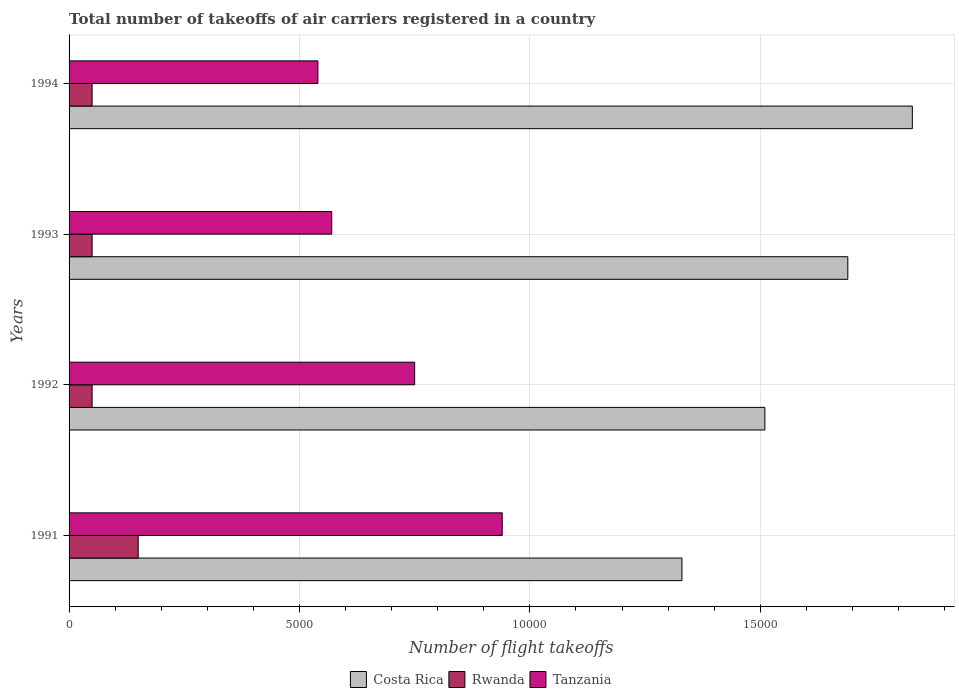How many different coloured bars are there?
Offer a terse response. 3. How many bars are there on the 4th tick from the top?
Your response must be concise. 3. In how many cases, is the number of bars for a given year not equal to the number of legend labels?
Offer a very short reply. 0. What is the total number of flight takeoffs in Tanzania in 1991?
Your response must be concise. 9400. Across all years, what is the maximum total number of flight takeoffs in Rwanda?
Offer a very short reply. 1500. What is the total total number of flight takeoffs in Rwanda in the graph?
Provide a succinct answer. 3000. What is the difference between the total number of flight takeoffs in Costa Rica in 1993 and that in 1994?
Your answer should be very brief. -1400. What is the difference between the total number of flight takeoffs in Rwanda in 1993 and the total number of flight takeoffs in Costa Rica in 1991?
Make the answer very short. -1.28e+04. What is the average total number of flight takeoffs in Costa Rica per year?
Keep it short and to the point. 1.59e+04. In the year 1994, what is the difference between the total number of flight takeoffs in Tanzania and total number of flight takeoffs in Costa Rica?
Offer a terse response. -1.29e+04. Is the difference between the total number of flight takeoffs in Tanzania in 1993 and 1994 greater than the difference between the total number of flight takeoffs in Costa Rica in 1993 and 1994?
Keep it short and to the point. Yes. What is the difference between the highest and the second highest total number of flight takeoffs in Tanzania?
Make the answer very short. 1900. What is the difference between the highest and the lowest total number of flight takeoffs in Rwanda?
Keep it short and to the point. 1000. In how many years, is the total number of flight takeoffs in Rwanda greater than the average total number of flight takeoffs in Rwanda taken over all years?
Provide a succinct answer. 1. Is the sum of the total number of flight takeoffs in Costa Rica in 1991 and 1994 greater than the maximum total number of flight takeoffs in Tanzania across all years?
Your answer should be very brief. Yes. What does the 1st bar from the top in 1993 represents?
Provide a short and direct response. Tanzania. What does the 2nd bar from the bottom in 1993 represents?
Provide a short and direct response. Rwanda. Is it the case that in every year, the sum of the total number of flight takeoffs in Rwanda and total number of flight takeoffs in Tanzania is greater than the total number of flight takeoffs in Costa Rica?
Give a very brief answer. No. How many bars are there?
Give a very brief answer. 12. What is the difference between two consecutive major ticks on the X-axis?
Provide a succinct answer. 5000. Are the values on the major ticks of X-axis written in scientific E-notation?
Ensure brevity in your answer.  No. Does the graph contain any zero values?
Your response must be concise. No. Does the graph contain grids?
Make the answer very short. Yes. Where does the legend appear in the graph?
Your answer should be very brief. Bottom center. How are the legend labels stacked?
Give a very brief answer. Horizontal. What is the title of the graph?
Provide a short and direct response. Total number of takeoffs of air carriers registered in a country. What is the label or title of the X-axis?
Give a very brief answer. Number of flight takeoffs. What is the Number of flight takeoffs of Costa Rica in 1991?
Your answer should be compact. 1.33e+04. What is the Number of flight takeoffs of Rwanda in 1991?
Your response must be concise. 1500. What is the Number of flight takeoffs of Tanzania in 1991?
Your answer should be compact. 9400. What is the Number of flight takeoffs of Costa Rica in 1992?
Offer a terse response. 1.51e+04. What is the Number of flight takeoffs of Tanzania in 1992?
Your response must be concise. 7500. What is the Number of flight takeoffs of Costa Rica in 1993?
Keep it short and to the point. 1.69e+04. What is the Number of flight takeoffs in Tanzania in 1993?
Your answer should be compact. 5700. What is the Number of flight takeoffs in Costa Rica in 1994?
Make the answer very short. 1.83e+04. What is the Number of flight takeoffs in Rwanda in 1994?
Keep it short and to the point. 500. What is the Number of flight takeoffs in Tanzania in 1994?
Your response must be concise. 5400. Across all years, what is the maximum Number of flight takeoffs of Costa Rica?
Ensure brevity in your answer.  1.83e+04. Across all years, what is the maximum Number of flight takeoffs in Rwanda?
Offer a very short reply. 1500. Across all years, what is the maximum Number of flight takeoffs in Tanzania?
Your answer should be compact. 9400. Across all years, what is the minimum Number of flight takeoffs of Costa Rica?
Make the answer very short. 1.33e+04. Across all years, what is the minimum Number of flight takeoffs of Tanzania?
Offer a very short reply. 5400. What is the total Number of flight takeoffs of Costa Rica in the graph?
Give a very brief answer. 6.36e+04. What is the total Number of flight takeoffs of Rwanda in the graph?
Your response must be concise. 3000. What is the total Number of flight takeoffs in Tanzania in the graph?
Make the answer very short. 2.80e+04. What is the difference between the Number of flight takeoffs of Costa Rica in 1991 and that in 1992?
Provide a short and direct response. -1800. What is the difference between the Number of flight takeoffs in Tanzania in 1991 and that in 1992?
Give a very brief answer. 1900. What is the difference between the Number of flight takeoffs in Costa Rica in 1991 and that in 1993?
Offer a terse response. -3600. What is the difference between the Number of flight takeoffs in Rwanda in 1991 and that in 1993?
Make the answer very short. 1000. What is the difference between the Number of flight takeoffs in Tanzania in 1991 and that in 1993?
Give a very brief answer. 3700. What is the difference between the Number of flight takeoffs of Costa Rica in 1991 and that in 1994?
Give a very brief answer. -5000. What is the difference between the Number of flight takeoffs in Rwanda in 1991 and that in 1994?
Provide a succinct answer. 1000. What is the difference between the Number of flight takeoffs of Tanzania in 1991 and that in 1994?
Ensure brevity in your answer.  4000. What is the difference between the Number of flight takeoffs in Costa Rica in 1992 and that in 1993?
Keep it short and to the point. -1800. What is the difference between the Number of flight takeoffs of Rwanda in 1992 and that in 1993?
Keep it short and to the point. 0. What is the difference between the Number of flight takeoffs of Tanzania in 1992 and that in 1993?
Your response must be concise. 1800. What is the difference between the Number of flight takeoffs in Costa Rica in 1992 and that in 1994?
Keep it short and to the point. -3200. What is the difference between the Number of flight takeoffs in Rwanda in 1992 and that in 1994?
Provide a short and direct response. 0. What is the difference between the Number of flight takeoffs in Tanzania in 1992 and that in 1994?
Your answer should be very brief. 2100. What is the difference between the Number of flight takeoffs of Costa Rica in 1993 and that in 1994?
Ensure brevity in your answer.  -1400. What is the difference between the Number of flight takeoffs in Tanzania in 1993 and that in 1994?
Provide a short and direct response. 300. What is the difference between the Number of flight takeoffs in Costa Rica in 1991 and the Number of flight takeoffs in Rwanda in 1992?
Keep it short and to the point. 1.28e+04. What is the difference between the Number of flight takeoffs of Costa Rica in 1991 and the Number of flight takeoffs of Tanzania in 1992?
Your answer should be compact. 5800. What is the difference between the Number of flight takeoffs of Rwanda in 1991 and the Number of flight takeoffs of Tanzania in 1992?
Make the answer very short. -6000. What is the difference between the Number of flight takeoffs of Costa Rica in 1991 and the Number of flight takeoffs of Rwanda in 1993?
Give a very brief answer. 1.28e+04. What is the difference between the Number of flight takeoffs in Costa Rica in 1991 and the Number of flight takeoffs in Tanzania in 1993?
Provide a succinct answer. 7600. What is the difference between the Number of flight takeoffs of Rwanda in 1991 and the Number of flight takeoffs of Tanzania in 1993?
Make the answer very short. -4200. What is the difference between the Number of flight takeoffs in Costa Rica in 1991 and the Number of flight takeoffs in Rwanda in 1994?
Keep it short and to the point. 1.28e+04. What is the difference between the Number of flight takeoffs in Costa Rica in 1991 and the Number of flight takeoffs in Tanzania in 1994?
Your answer should be very brief. 7900. What is the difference between the Number of flight takeoffs in Rwanda in 1991 and the Number of flight takeoffs in Tanzania in 1994?
Offer a very short reply. -3900. What is the difference between the Number of flight takeoffs in Costa Rica in 1992 and the Number of flight takeoffs in Rwanda in 1993?
Provide a succinct answer. 1.46e+04. What is the difference between the Number of flight takeoffs of Costa Rica in 1992 and the Number of flight takeoffs of Tanzania in 1993?
Ensure brevity in your answer.  9400. What is the difference between the Number of flight takeoffs in Rwanda in 1992 and the Number of flight takeoffs in Tanzania in 1993?
Your answer should be very brief. -5200. What is the difference between the Number of flight takeoffs in Costa Rica in 1992 and the Number of flight takeoffs in Rwanda in 1994?
Ensure brevity in your answer.  1.46e+04. What is the difference between the Number of flight takeoffs in Costa Rica in 1992 and the Number of flight takeoffs in Tanzania in 1994?
Offer a terse response. 9700. What is the difference between the Number of flight takeoffs of Rwanda in 1992 and the Number of flight takeoffs of Tanzania in 1994?
Give a very brief answer. -4900. What is the difference between the Number of flight takeoffs of Costa Rica in 1993 and the Number of flight takeoffs of Rwanda in 1994?
Ensure brevity in your answer.  1.64e+04. What is the difference between the Number of flight takeoffs of Costa Rica in 1993 and the Number of flight takeoffs of Tanzania in 1994?
Make the answer very short. 1.15e+04. What is the difference between the Number of flight takeoffs of Rwanda in 1993 and the Number of flight takeoffs of Tanzania in 1994?
Provide a succinct answer. -4900. What is the average Number of flight takeoffs of Costa Rica per year?
Your answer should be compact. 1.59e+04. What is the average Number of flight takeoffs of Rwanda per year?
Ensure brevity in your answer.  750. What is the average Number of flight takeoffs of Tanzania per year?
Your answer should be very brief. 7000. In the year 1991, what is the difference between the Number of flight takeoffs in Costa Rica and Number of flight takeoffs in Rwanda?
Provide a short and direct response. 1.18e+04. In the year 1991, what is the difference between the Number of flight takeoffs of Costa Rica and Number of flight takeoffs of Tanzania?
Ensure brevity in your answer.  3900. In the year 1991, what is the difference between the Number of flight takeoffs in Rwanda and Number of flight takeoffs in Tanzania?
Provide a succinct answer. -7900. In the year 1992, what is the difference between the Number of flight takeoffs of Costa Rica and Number of flight takeoffs of Rwanda?
Your answer should be very brief. 1.46e+04. In the year 1992, what is the difference between the Number of flight takeoffs in Costa Rica and Number of flight takeoffs in Tanzania?
Provide a succinct answer. 7600. In the year 1992, what is the difference between the Number of flight takeoffs in Rwanda and Number of flight takeoffs in Tanzania?
Make the answer very short. -7000. In the year 1993, what is the difference between the Number of flight takeoffs of Costa Rica and Number of flight takeoffs of Rwanda?
Offer a terse response. 1.64e+04. In the year 1993, what is the difference between the Number of flight takeoffs of Costa Rica and Number of flight takeoffs of Tanzania?
Offer a terse response. 1.12e+04. In the year 1993, what is the difference between the Number of flight takeoffs of Rwanda and Number of flight takeoffs of Tanzania?
Provide a short and direct response. -5200. In the year 1994, what is the difference between the Number of flight takeoffs of Costa Rica and Number of flight takeoffs of Rwanda?
Provide a short and direct response. 1.78e+04. In the year 1994, what is the difference between the Number of flight takeoffs of Costa Rica and Number of flight takeoffs of Tanzania?
Your answer should be very brief. 1.29e+04. In the year 1994, what is the difference between the Number of flight takeoffs of Rwanda and Number of flight takeoffs of Tanzania?
Keep it short and to the point. -4900. What is the ratio of the Number of flight takeoffs in Costa Rica in 1991 to that in 1992?
Your answer should be compact. 0.88. What is the ratio of the Number of flight takeoffs of Rwanda in 1991 to that in 1992?
Provide a succinct answer. 3. What is the ratio of the Number of flight takeoffs of Tanzania in 1991 to that in 1992?
Provide a short and direct response. 1.25. What is the ratio of the Number of flight takeoffs of Costa Rica in 1991 to that in 1993?
Give a very brief answer. 0.79. What is the ratio of the Number of flight takeoffs in Rwanda in 1991 to that in 1993?
Your response must be concise. 3. What is the ratio of the Number of flight takeoffs of Tanzania in 1991 to that in 1993?
Your response must be concise. 1.65. What is the ratio of the Number of flight takeoffs of Costa Rica in 1991 to that in 1994?
Ensure brevity in your answer.  0.73. What is the ratio of the Number of flight takeoffs in Tanzania in 1991 to that in 1994?
Provide a short and direct response. 1.74. What is the ratio of the Number of flight takeoffs of Costa Rica in 1992 to that in 1993?
Your answer should be compact. 0.89. What is the ratio of the Number of flight takeoffs of Tanzania in 1992 to that in 1993?
Your answer should be very brief. 1.32. What is the ratio of the Number of flight takeoffs in Costa Rica in 1992 to that in 1994?
Offer a very short reply. 0.83. What is the ratio of the Number of flight takeoffs in Rwanda in 1992 to that in 1994?
Your answer should be very brief. 1. What is the ratio of the Number of flight takeoffs in Tanzania in 1992 to that in 1994?
Give a very brief answer. 1.39. What is the ratio of the Number of flight takeoffs of Costa Rica in 1993 to that in 1994?
Your answer should be very brief. 0.92. What is the ratio of the Number of flight takeoffs of Rwanda in 1993 to that in 1994?
Keep it short and to the point. 1. What is the ratio of the Number of flight takeoffs of Tanzania in 1993 to that in 1994?
Provide a succinct answer. 1.06. What is the difference between the highest and the second highest Number of flight takeoffs of Costa Rica?
Provide a short and direct response. 1400. What is the difference between the highest and the second highest Number of flight takeoffs in Tanzania?
Offer a terse response. 1900. What is the difference between the highest and the lowest Number of flight takeoffs in Tanzania?
Keep it short and to the point. 4000. 